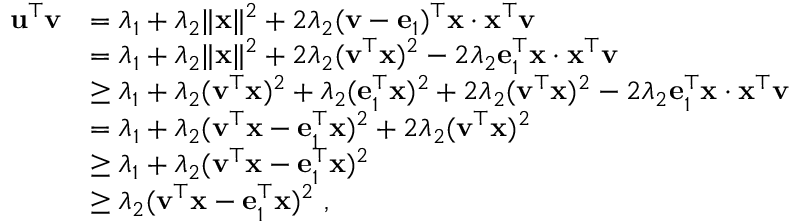<formula> <loc_0><loc_0><loc_500><loc_500>\begin{array} { r l } { \mathbf u ^ { \top } \mathbf v } & { = \lambda _ { 1 } + \lambda _ { 2 } \| { \mathbf x } \| ^ { 2 } + 2 \lambda _ { 2 } ( \mathbf v - \mathbf e _ { 1 } ) ^ { \top } \mathbf x \cdot \mathbf x ^ { \top } \mathbf v } \\ & { = \lambda _ { 1 } + \lambda _ { 2 } \| { \mathbf x } \| ^ { 2 } + 2 \lambda _ { 2 } ( \mathbf v ^ { \top } \mathbf x ) ^ { 2 } - 2 \lambda _ { 2 } \mathbf e _ { 1 } ^ { \top } \mathbf x \cdot \mathbf x ^ { \top } \mathbf v } \\ & { \geq \lambda _ { 1 } + \lambda _ { 2 } ( \mathbf v ^ { \top } \mathbf x ) ^ { 2 } + \lambda _ { 2 } ( \mathbf e _ { 1 } ^ { \top } \mathbf x ) ^ { 2 } + 2 \lambda _ { 2 } ( \mathbf v ^ { \top } \mathbf x ) ^ { 2 } - 2 \lambda _ { 2 } \mathbf e _ { 1 } ^ { \top } \mathbf x \cdot \mathbf x ^ { \top } \mathbf v } \\ & { = \lambda _ { 1 } + \lambda _ { 2 } ( \mathbf v ^ { \top } \mathbf x - \mathbf e _ { 1 } ^ { \top } \mathbf x ) ^ { 2 } + 2 \lambda _ { 2 } ( \mathbf v ^ { \top } \mathbf x ) ^ { 2 } } \\ & { \geq \lambda _ { 1 } + \lambda _ { 2 } ( \mathbf v ^ { \top } \mathbf x - \mathbf e _ { 1 } ^ { \top } \mathbf x ) ^ { 2 } } \\ & { \geq \lambda _ { 2 } ( \mathbf v ^ { \top } \mathbf x - \mathbf e _ { 1 } ^ { \top } \mathbf x ) ^ { 2 } , } \end{array}</formula> 